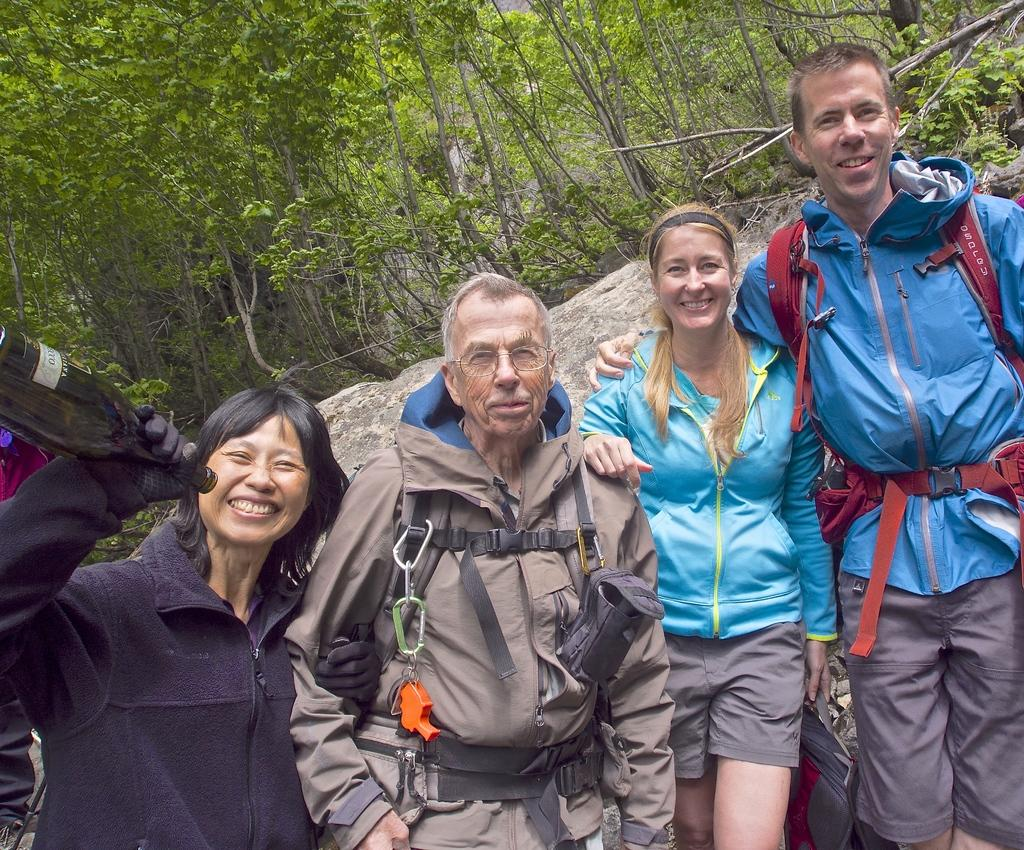How many people are in the group in the image? There is a group of people in the image, but the exact number is not specified. What is the person wearing in the group? One person in the group is wearing a brown dress. What can be seen in the background of the image? There are rocks and trees with green leaves in the background of the image. How many lizards are sitting on the person wearing the brown dress in the image? There are no lizards present in the image. What type of dolls can be seen playing with the trees in the background? There are no dolls present in the image, and the trees are not depicted as playing with anything. 